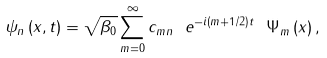<formula> <loc_0><loc_0><loc_500><loc_500>\psi _ { n } \left ( x , t \right ) = \sqrt { \beta _ { 0 } } \sum _ { m = 0 } ^ { \infty } c _ { m n } \ e ^ { - i \left ( m + 1 / 2 \right ) t } \ \Psi _ { m } \left ( x \right ) ,</formula> 